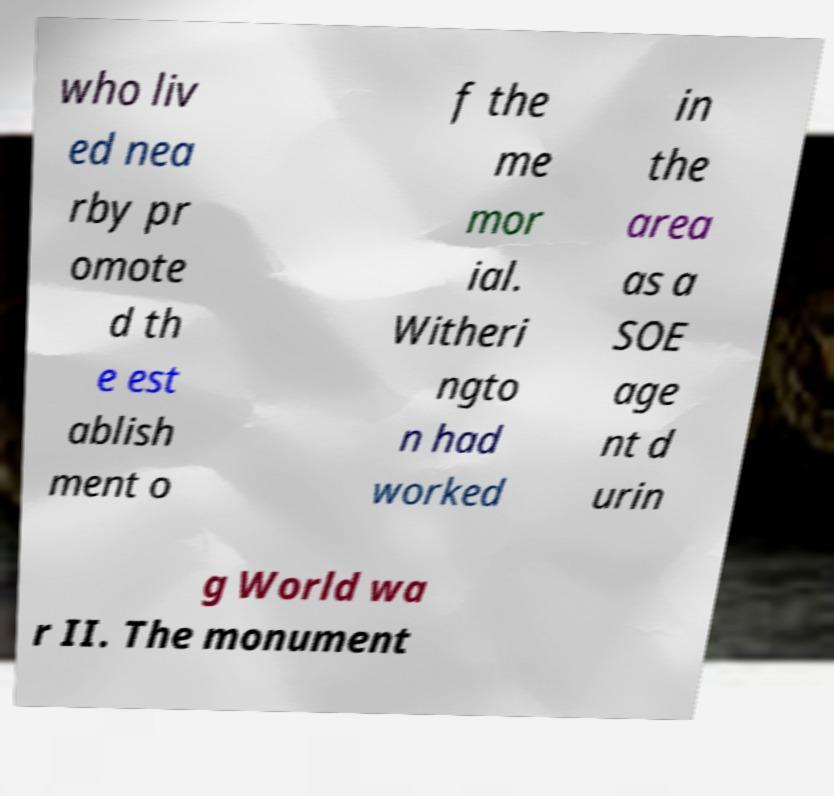There's text embedded in this image that I need extracted. Can you transcribe it verbatim? who liv ed nea rby pr omote d th e est ablish ment o f the me mor ial. Witheri ngto n had worked in the area as a SOE age nt d urin g World wa r II. The monument 